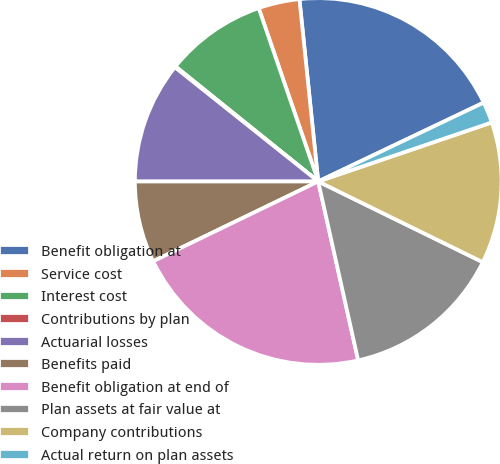Convert chart. <chart><loc_0><loc_0><loc_500><loc_500><pie_chart><fcel>Benefit obligation at<fcel>Service cost<fcel>Interest cost<fcel>Contributions by plan<fcel>Actuarial losses<fcel>Benefits paid<fcel>Benefit obligation at end of<fcel>Plan assets at fair value at<fcel>Company contributions<fcel>Actual return on plan assets<nl><fcel>19.56%<fcel>3.63%<fcel>8.94%<fcel>0.09%<fcel>10.71%<fcel>7.17%<fcel>21.33%<fcel>14.25%<fcel>12.48%<fcel>1.86%<nl></chart> 